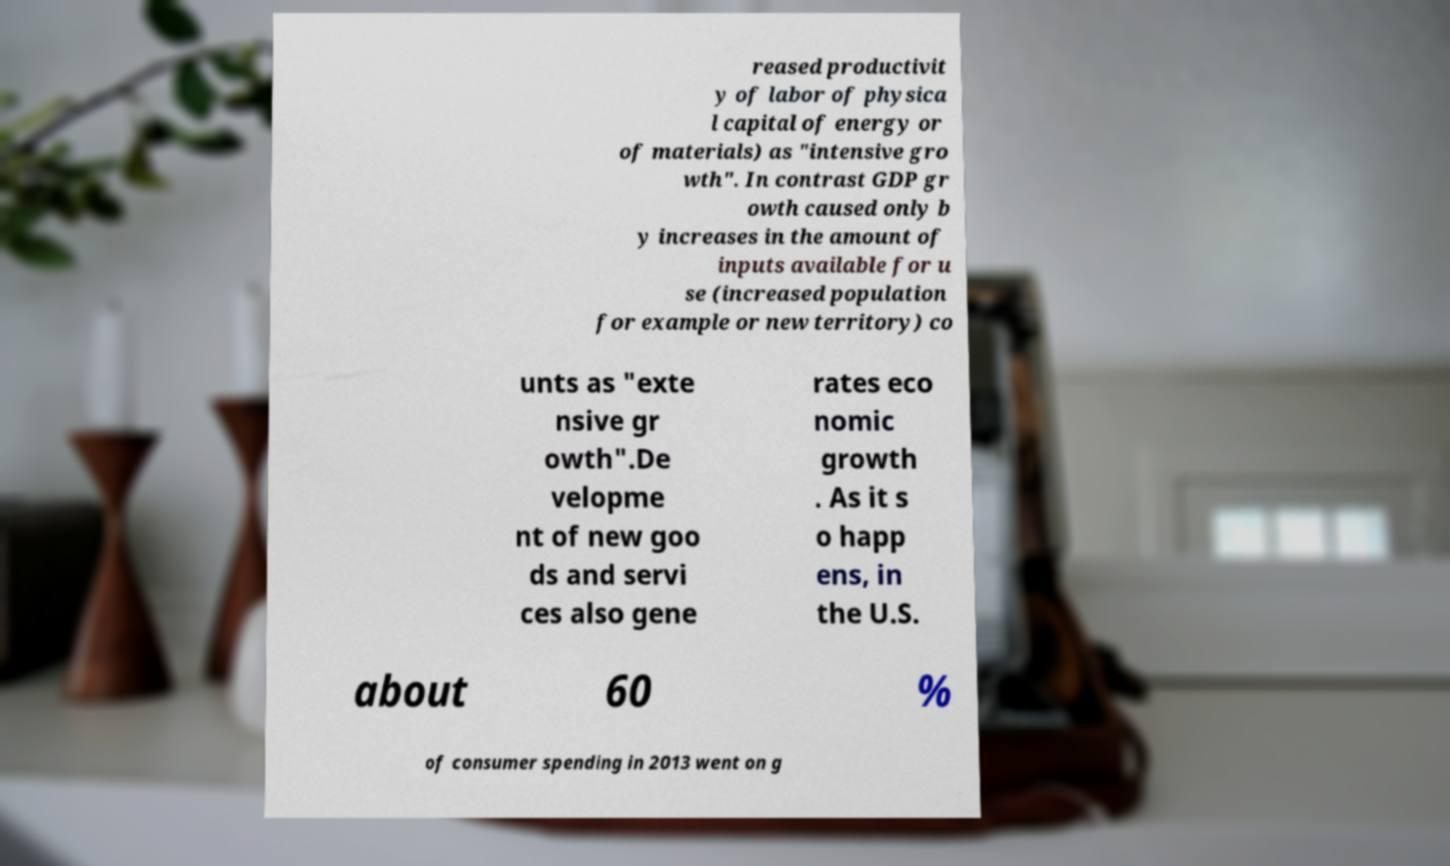I need the written content from this picture converted into text. Can you do that? reased productivit y of labor of physica l capital of energy or of materials) as "intensive gro wth". In contrast GDP gr owth caused only b y increases in the amount of inputs available for u se (increased population for example or new territory) co unts as "exte nsive gr owth".De velopme nt of new goo ds and servi ces also gene rates eco nomic growth . As it s o happ ens, in the U.S. about 60 % of consumer spending in 2013 went on g 